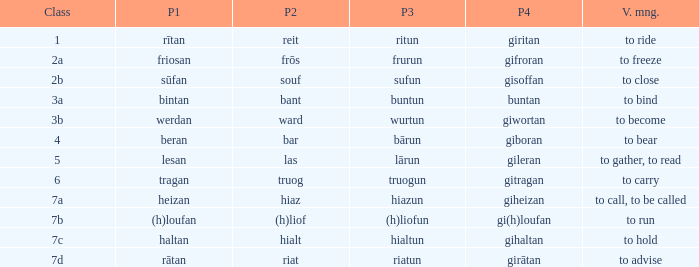What is the part 3 of the word in class 7a? Hiazun. 